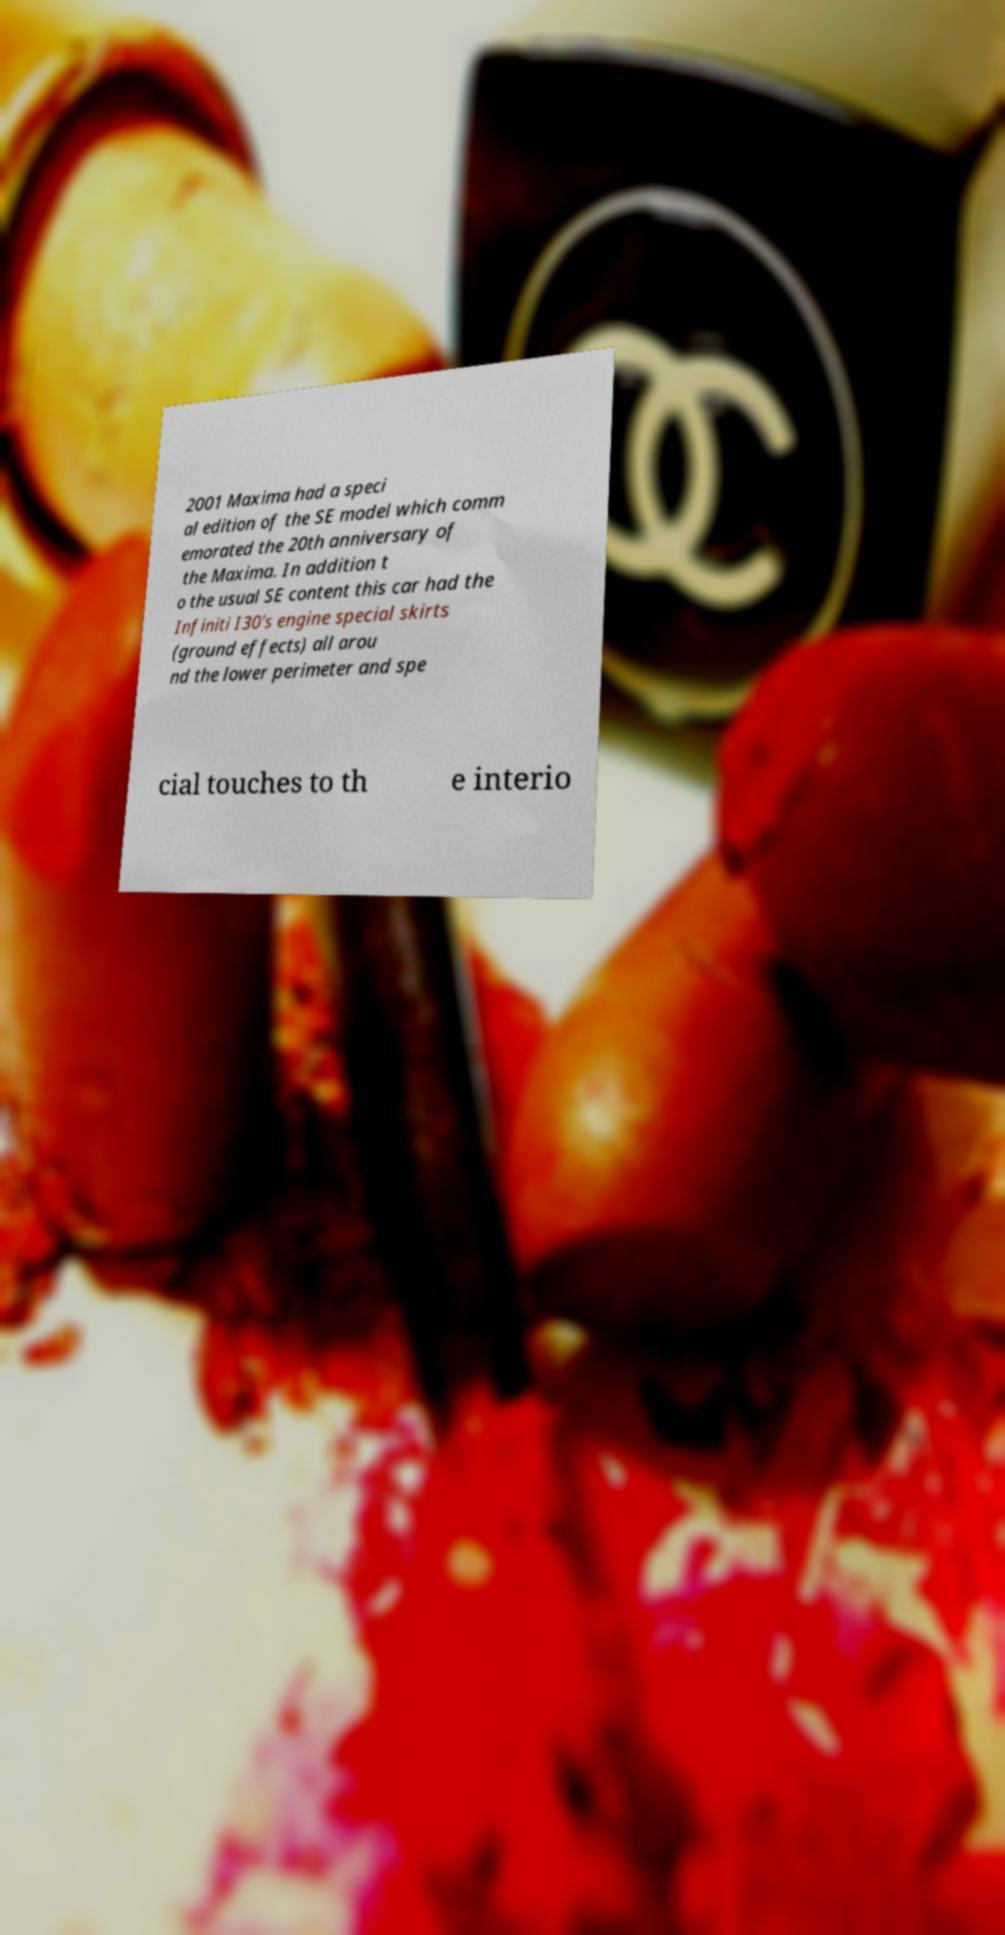Can you read and provide the text displayed in the image?This photo seems to have some interesting text. Can you extract and type it out for me? 2001 Maxima had a speci al edition of the SE model which comm emorated the 20th anniversary of the Maxima. In addition t o the usual SE content this car had the Infiniti I30's engine special skirts (ground effects) all arou nd the lower perimeter and spe cial touches to th e interio 